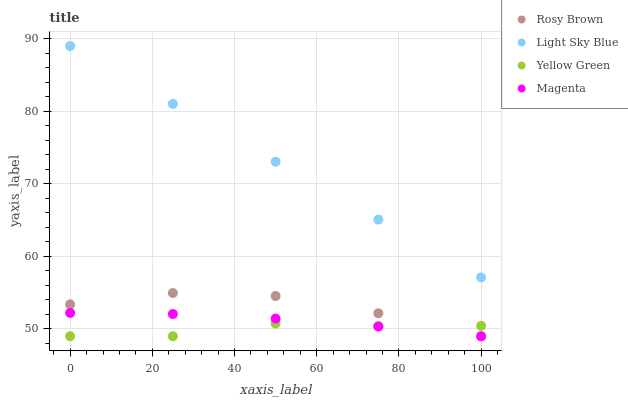Does Yellow Green have the minimum area under the curve?
Answer yes or no. Yes. Does Light Sky Blue have the maximum area under the curve?
Answer yes or no. Yes. Does Rosy Brown have the minimum area under the curve?
Answer yes or no. No. Does Rosy Brown have the maximum area under the curve?
Answer yes or no. No. Is Light Sky Blue the smoothest?
Answer yes or no. Yes. Is Rosy Brown the roughest?
Answer yes or no. Yes. Is Yellow Green the smoothest?
Answer yes or no. No. Is Yellow Green the roughest?
Answer yes or no. No. Does Magenta have the lowest value?
Answer yes or no. Yes. Does Light Sky Blue have the lowest value?
Answer yes or no. No. Does Light Sky Blue have the highest value?
Answer yes or no. Yes. Does Rosy Brown have the highest value?
Answer yes or no. No. Is Yellow Green less than Light Sky Blue?
Answer yes or no. Yes. Is Light Sky Blue greater than Magenta?
Answer yes or no. Yes. Does Rosy Brown intersect Magenta?
Answer yes or no. Yes. Is Rosy Brown less than Magenta?
Answer yes or no. No. Is Rosy Brown greater than Magenta?
Answer yes or no. No. Does Yellow Green intersect Light Sky Blue?
Answer yes or no. No. 